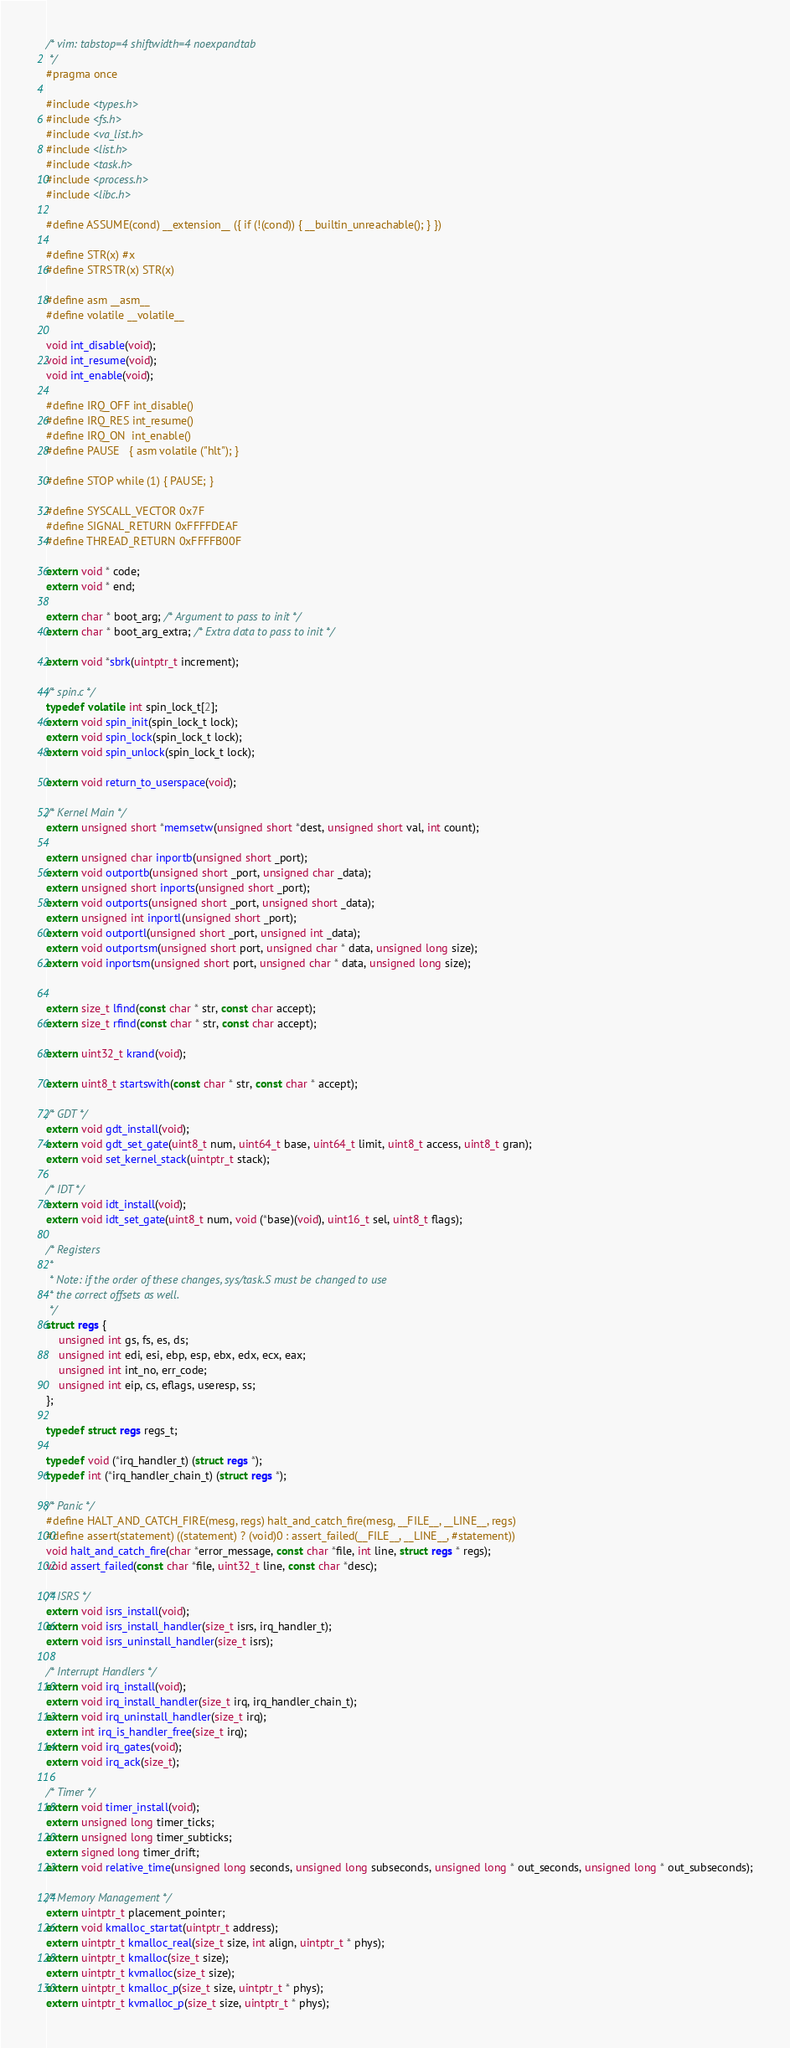Convert code to text. <code><loc_0><loc_0><loc_500><loc_500><_C_>/* vim: tabstop=4 shiftwidth=4 noexpandtab
 */
#pragma once

#include <types.h>
#include <fs.h>
#include <va_list.h>
#include <list.h>
#include <task.h>
#include <process.h>
#include <libc.h>

#define ASSUME(cond) __extension__ ({ if (!(cond)) { __builtin_unreachable(); } })

#define STR(x) #x
#define STRSTR(x) STR(x)

#define asm __asm__
#define volatile __volatile__

void int_disable(void);
void int_resume(void);
void int_enable(void);

#define IRQ_OFF int_disable()
#define IRQ_RES int_resume()
#define IRQ_ON  int_enable()
#define PAUSE   { asm volatile ("hlt"); }

#define STOP while (1) { PAUSE; }

#define SYSCALL_VECTOR 0x7F
#define SIGNAL_RETURN 0xFFFFDEAF
#define THREAD_RETURN 0xFFFFB00F

extern void * code;
extern void * end;

extern char * boot_arg; /* Argument to pass to init */
extern char * boot_arg_extra; /* Extra data to pass to init */

extern void *sbrk(uintptr_t increment);

/* spin.c */
typedef volatile int spin_lock_t[2];
extern void spin_init(spin_lock_t lock);
extern void spin_lock(spin_lock_t lock);
extern void spin_unlock(spin_lock_t lock);

extern void return_to_userspace(void);

/* Kernel Main */
extern unsigned short *memsetw(unsigned short *dest, unsigned short val, int count);

extern unsigned char inportb(unsigned short _port);
extern void outportb(unsigned short _port, unsigned char _data);
extern unsigned short inports(unsigned short _port);
extern void outports(unsigned short _port, unsigned short _data);
extern unsigned int inportl(unsigned short _port);
extern void outportl(unsigned short _port, unsigned int _data);
extern void outportsm(unsigned short port, unsigned char * data, unsigned long size);
extern void inportsm(unsigned short port, unsigned char * data, unsigned long size);


extern size_t lfind(const char * str, const char accept);
extern size_t rfind(const char * str, const char accept);

extern uint32_t krand(void);

extern uint8_t startswith(const char * str, const char * accept);

/* GDT */
extern void gdt_install(void);
extern void gdt_set_gate(uint8_t num, uint64_t base, uint64_t limit, uint8_t access, uint8_t gran);
extern void set_kernel_stack(uintptr_t stack);

/* IDT */
extern void idt_install(void);
extern void idt_set_gate(uint8_t num, void (*base)(void), uint16_t sel, uint8_t flags);

/* Registers
 *
 * Note: if the order of these changes, sys/task.S must be changed to use
 * the correct offsets as well.
 */
struct regs {
	unsigned int gs, fs, es, ds;
	unsigned int edi, esi, ebp, esp, ebx, edx, ecx, eax;
	unsigned int int_no, err_code;
	unsigned int eip, cs, eflags, useresp, ss;
};

typedef struct regs regs_t;

typedef void (*irq_handler_t) (struct regs *);
typedef int (*irq_handler_chain_t) (struct regs *);

/* Panic */
#define HALT_AND_CATCH_FIRE(mesg, regs) halt_and_catch_fire(mesg, __FILE__, __LINE__, regs)
#define assert(statement) ((statement) ? (void)0 : assert_failed(__FILE__, __LINE__, #statement))
void halt_and_catch_fire(char *error_message, const char *file, int line, struct regs * regs);
void assert_failed(const char *file, uint32_t line, const char *desc);

/* ISRS */
extern void isrs_install(void);
extern void isrs_install_handler(size_t isrs, irq_handler_t);
extern void isrs_uninstall_handler(size_t isrs);

/* Interrupt Handlers */
extern void irq_install(void);
extern void irq_install_handler(size_t irq, irq_handler_chain_t);
extern void irq_uninstall_handler(size_t irq);
extern int irq_is_handler_free(size_t irq);
extern void irq_gates(void);
extern void irq_ack(size_t);

/* Timer */
extern void timer_install(void);
extern unsigned long timer_ticks;
extern unsigned long timer_subticks;
extern signed long timer_drift;
extern void relative_time(unsigned long seconds, unsigned long subseconds, unsigned long * out_seconds, unsigned long * out_subseconds);

/* Memory Management */
extern uintptr_t placement_pointer;
extern void kmalloc_startat(uintptr_t address);
extern uintptr_t kmalloc_real(size_t size, int align, uintptr_t * phys);
extern uintptr_t kmalloc(size_t size);
extern uintptr_t kvmalloc(size_t size);
extern uintptr_t kmalloc_p(size_t size, uintptr_t * phys);
extern uintptr_t kvmalloc_p(size_t size, uintptr_t * phys);
</code> 